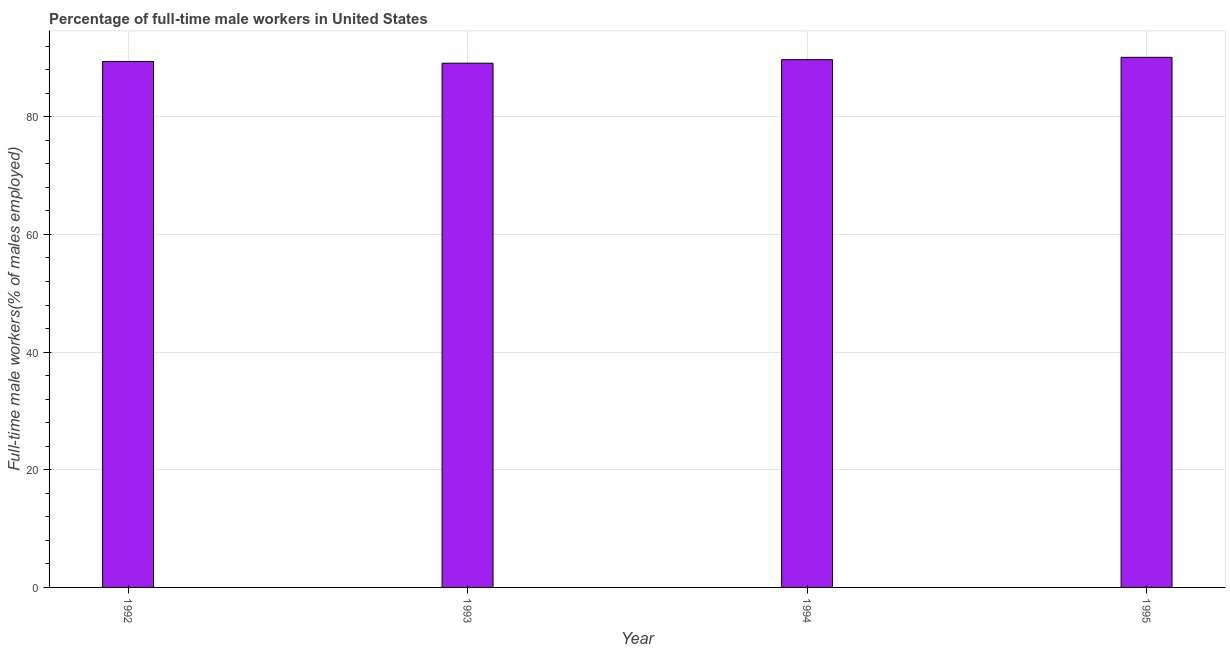Does the graph contain grids?
Ensure brevity in your answer.  Yes. What is the title of the graph?
Your answer should be compact. Percentage of full-time male workers in United States. What is the label or title of the X-axis?
Provide a succinct answer. Year. What is the label or title of the Y-axis?
Give a very brief answer. Full-time male workers(% of males employed). What is the percentage of full-time male workers in 1995?
Offer a very short reply. 90.1. Across all years, what is the maximum percentage of full-time male workers?
Offer a terse response. 90.1. Across all years, what is the minimum percentage of full-time male workers?
Provide a short and direct response. 89.1. In which year was the percentage of full-time male workers minimum?
Offer a very short reply. 1993. What is the sum of the percentage of full-time male workers?
Give a very brief answer. 358.3. What is the difference between the percentage of full-time male workers in 1992 and 1993?
Your response must be concise. 0.3. What is the average percentage of full-time male workers per year?
Your response must be concise. 89.58. What is the median percentage of full-time male workers?
Make the answer very short. 89.55. In how many years, is the percentage of full-time male workers greater than 84 %?
Your response must be concise. 4. Do a majority of the years between 1993 and 1992 (inclusive) have percentage of full-time male workers greater than 88 %?
Give a very brief answer. No. What is the ratio of the percentage of full-time male workers in 1994 to that in 1995?
Keep it short and to the point. 1. Is the sum of the percentage of full-time male workers in 1992 and 1993 greater than the maximum percentage of full-time male workers across all years?
Offer a very short reply. Yes. How many bars are there?
Ensure brevity in your answer.  4. Are all the bars in the graph horizontal?
Offer a terse response. No. How many years are there in the graph?
Offer a terse response. 4. What is the difference between two consecutive major ticks on the Y-axis?
Your answer should be compact. 20. What is the Full-time male workers(% of males employed) in 1992?
Your answer should be very brief. 89.4. What is the Full-time male workers(% of males employed) of 1993?
Your answer should be very brief. 89.1. What is the Full-time male workers(% of males employed) of 1994?
Give a very brief answer. 89.7. What is the Full-time male workers(% of males employed) in 1995?
Your answer should be very brief. 90.1. What is the difference between the Full-time male workers(% of males employed) in 1993 and 1994?
Provide a short and direct response. -0.6. What is the difference between the Full-time male workers(% of males employed) in 1993 and 1995?
Give a very brief answer. -1. What is the difference between the Full-time male workers(% of males employed) in 1994 and 1995?
Your answer should be compact. -0.4. What is the ratio of the Full-time male workers(% of males employed) in 1992 to that in 1994?
Make the answer very short. 1. What is the ratio of the Full-time male workers(% of males employed) in 1993 to that in 1994?
Provide a short and direct response. 0.99. What is the ratio of the Full-time male workers(% of males employed) in 1994 to that in 1995?
Ensure brevity in your answer.  1. 